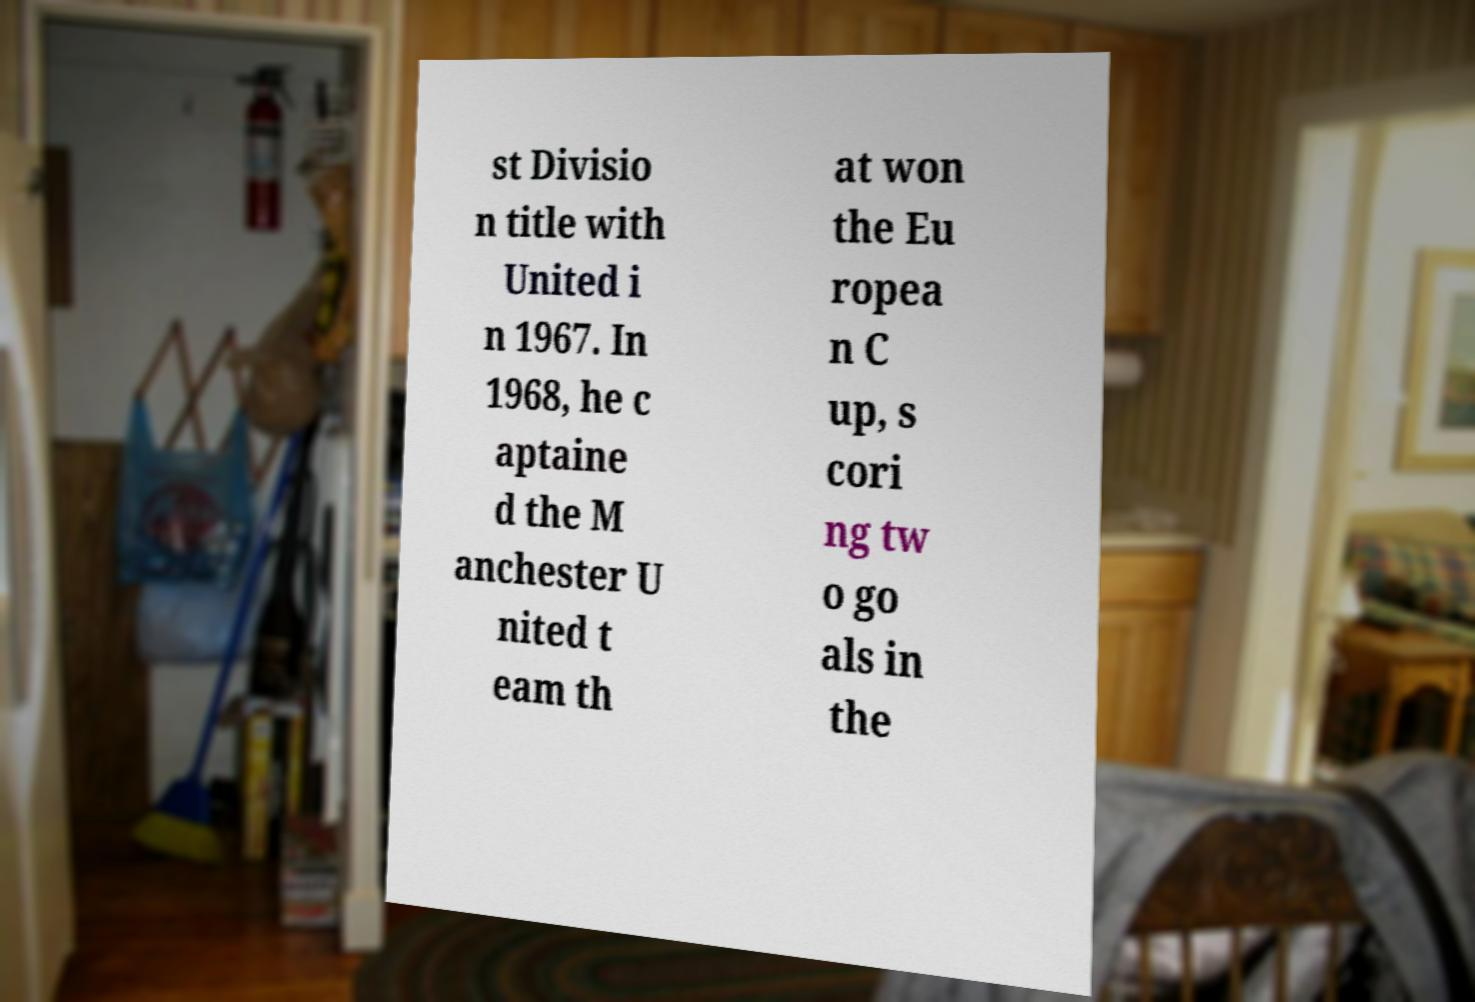Please read and relay the text visible in this image. What does it say? st Divisio n title with United i n 1967. In 1968, he c aptaine d the M anchester U nited t eam th at won the Eu ropea n C up, s cori ng tw o go als in the 